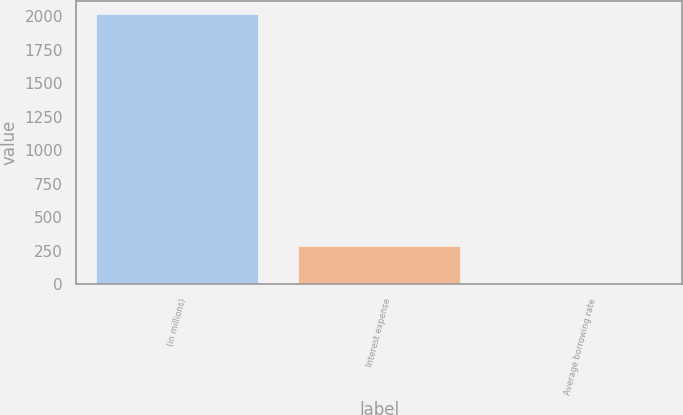Convert chart. <chart><loc_0><loc_0><loc_500><loc_500><bar_chart><fcel>(in millions)<fcel>Interest expense<fcel>Average borrowing rate<nl><fcel>2015<fcel>284<fcel>5.2<nl></chart> 